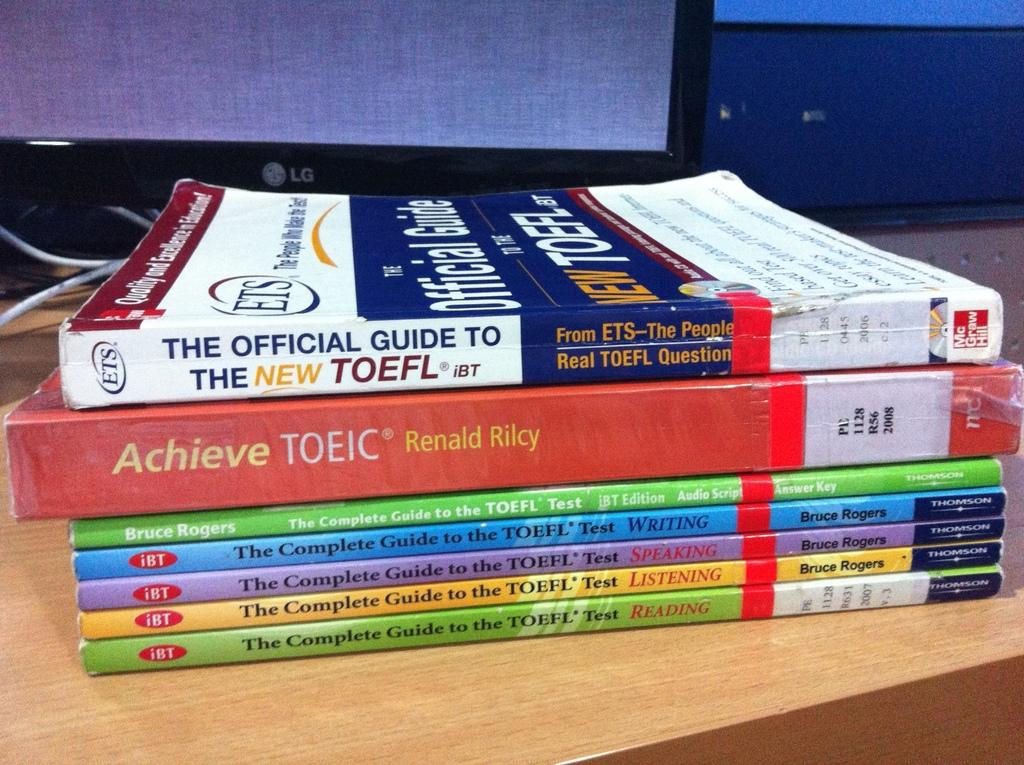<image>
Give a short and clear explanation of the subsequent image. The thick red book is written by Renald Rilcy 